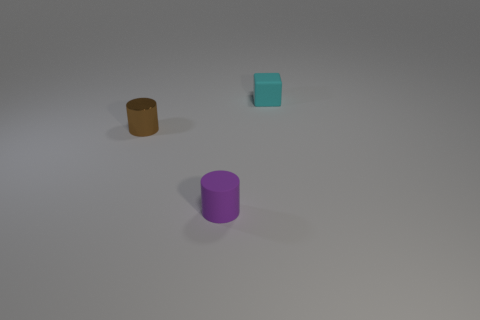Add 2 small cyan things. How many objects exist? 5 Subtract all blocks. How many objects are left? 2 Subtract all gray cylinders. Subtract all brown blocks. How many cylinders are left? 2 Subtract all rubber things. Subtract all rubber blocks. How many objects are left? 0 Add 1 tiny brown shiny cylinders. How many tiny brown shiny cylinders are left? 2 Add 2 tiny purple cylinders. How many tiny purple cylinders exist? 3 Subtract 1 purple cylinders. How many objects are left? 2 